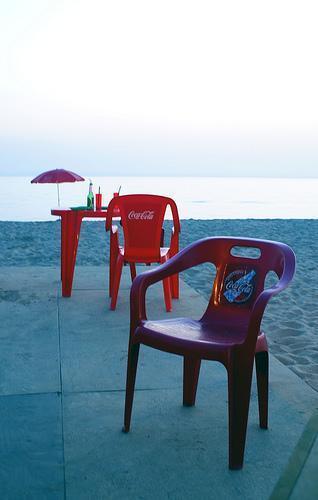How many chairs are there?
Give a very brief answer. 2. How many tables are there?
Give a very brief answer. 1. 